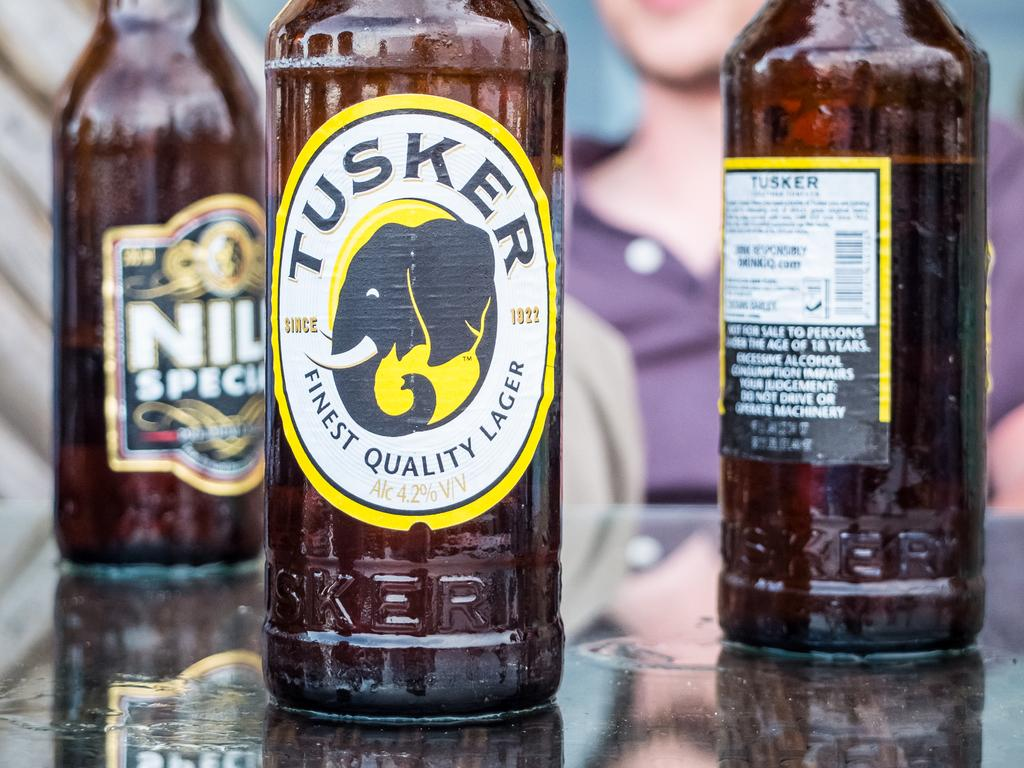<image>
Render a clear and concise summary of the photo. A bottle of Tusker beer sits near a bottle of NIU beer 